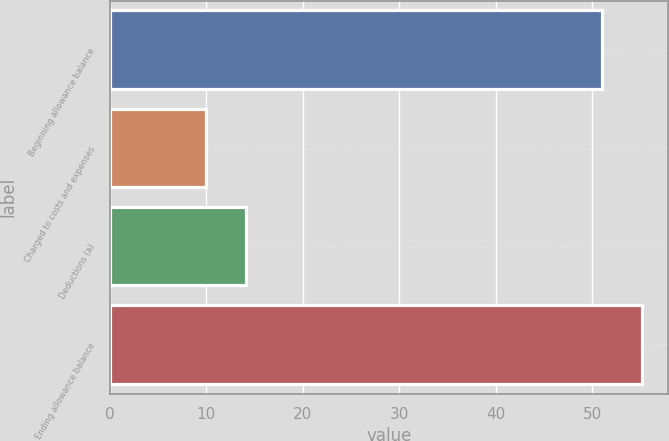Convert chart. <chart><loc_0><loc_0><loc_500><loc_500><bar_chart><fcel>Beginning allowance balance<fcel>Charged to costs and expenses<fcel>Deductions (a)<fcel>Ending allowance balance<nl><fcel>51<fcel>10<fcel>14.1<fcel>55.1<nl></chart> 